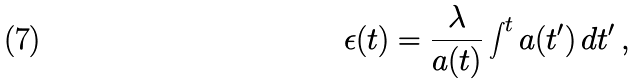Convert formula to latex. <formula><loc_0><loc_0><loc_500><loc_500>\epsilon ( t ) = \frac { \lambda } { a ( t ) } \int ^ { t } a ( t ^ { \prime } ) \, d t ^ { \prime } \, ,</formula> 